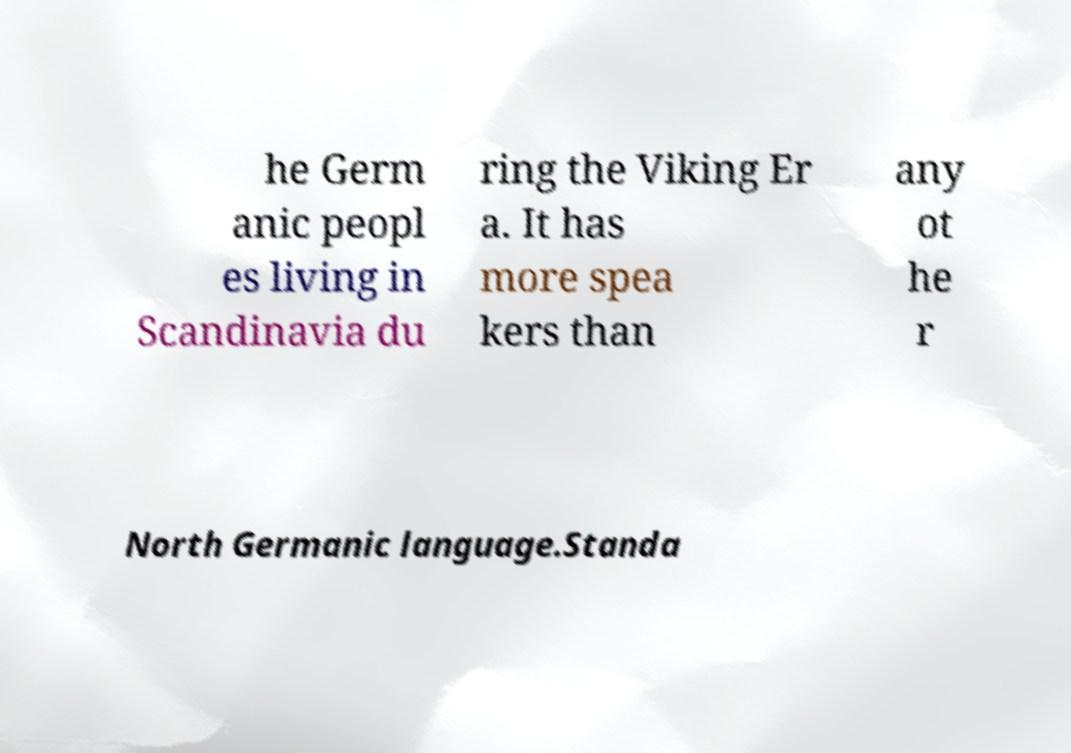Please read and relay the text visible in this image. What does it say? he Germ anic peopl es living in Scandinavia du ring the Viking Er a. It has more spea kers than any ot he r North Germanic language.Standa 